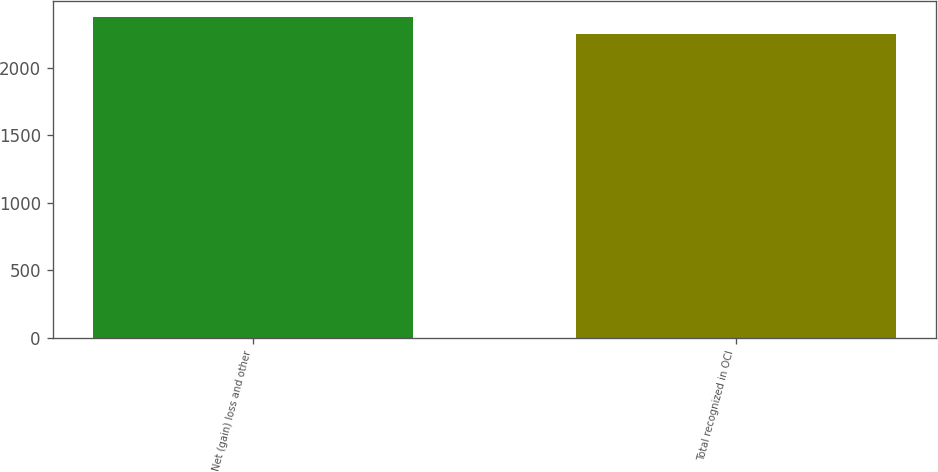Convert chart to OTSL. <chart><loc_0><loc_0><loc_500><loc_500><bar_chart><fcel>Net (gain) loss and other<fcel>Total recognized in OCI<nl><fcel>2371<fcel>2247<nl></chart> 